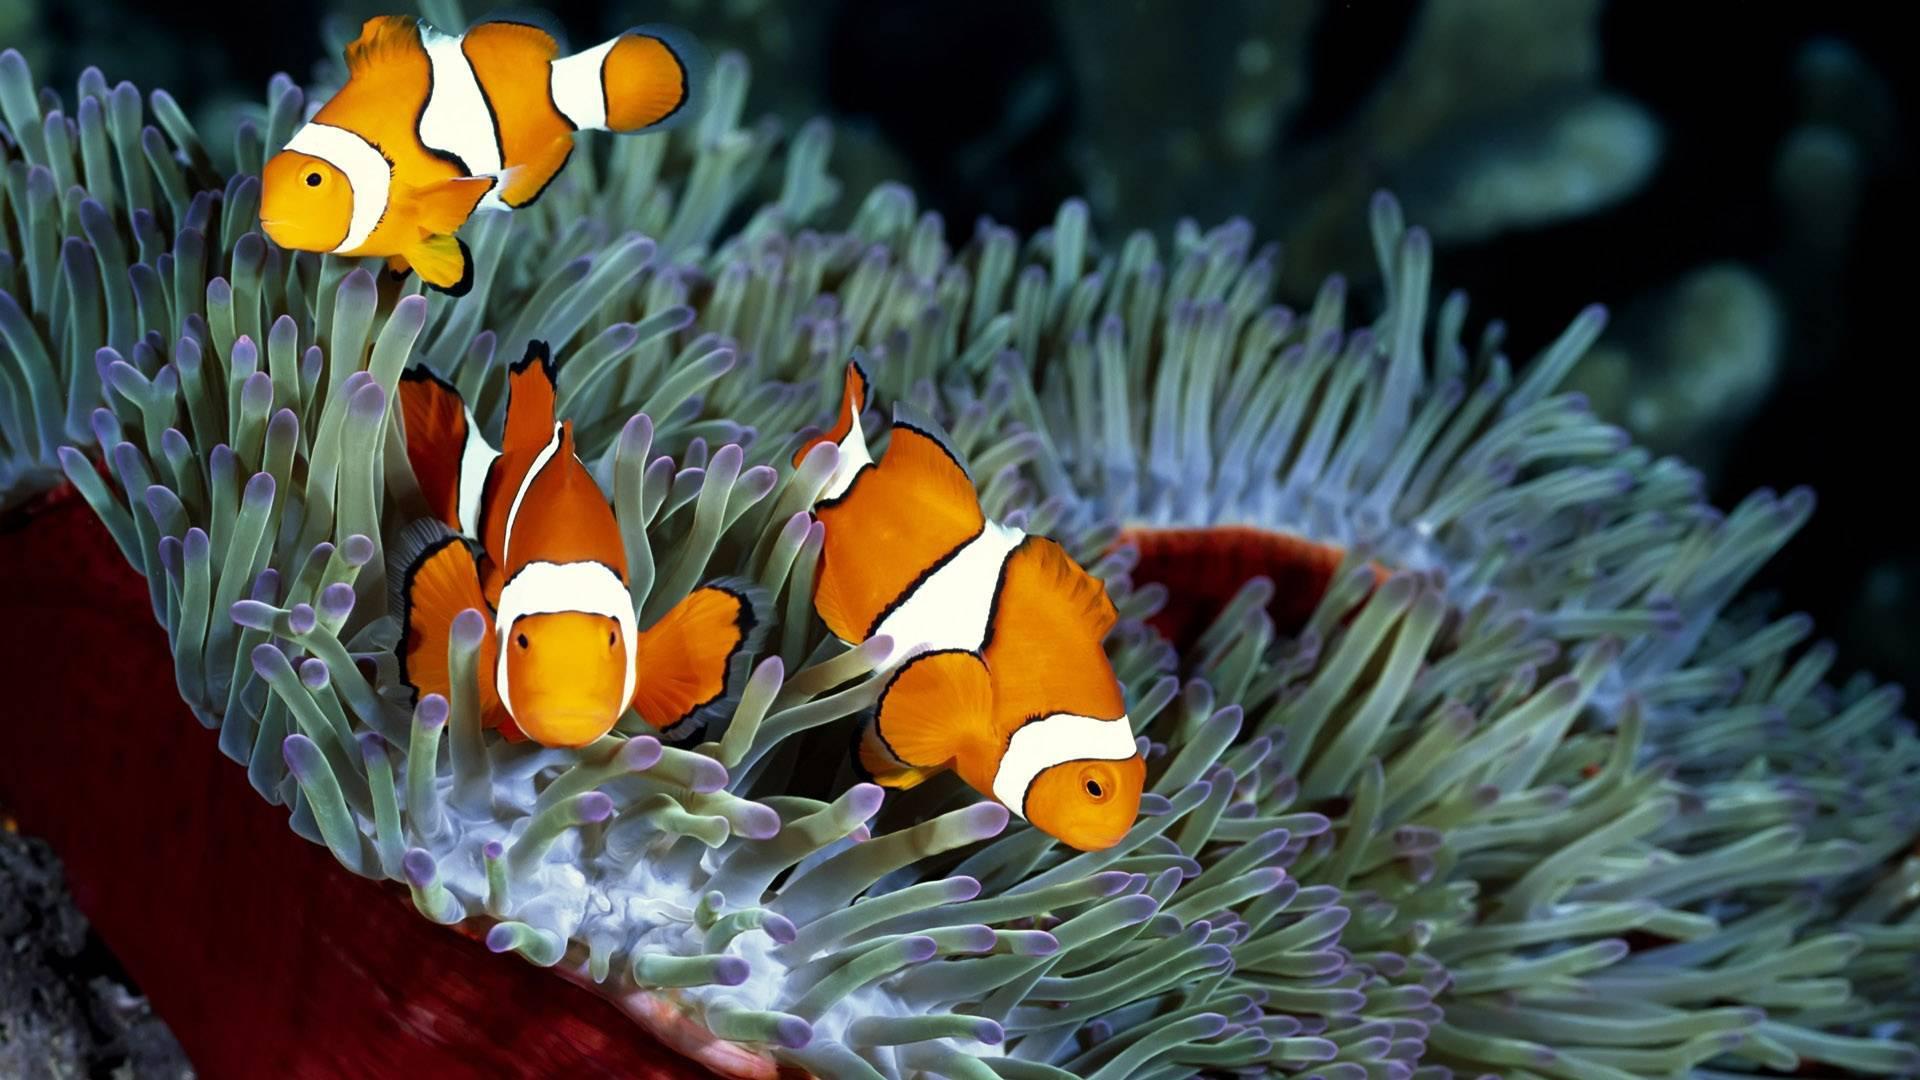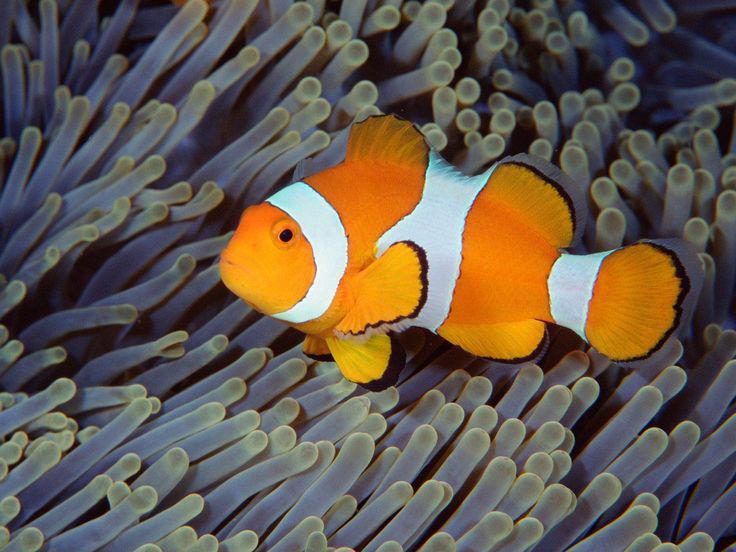The first image is the image on the left, the second image is the image on the right. Considering the images on both sides, is "there is only clownfish on the right image" valid? Answer yes or no. Yes. 